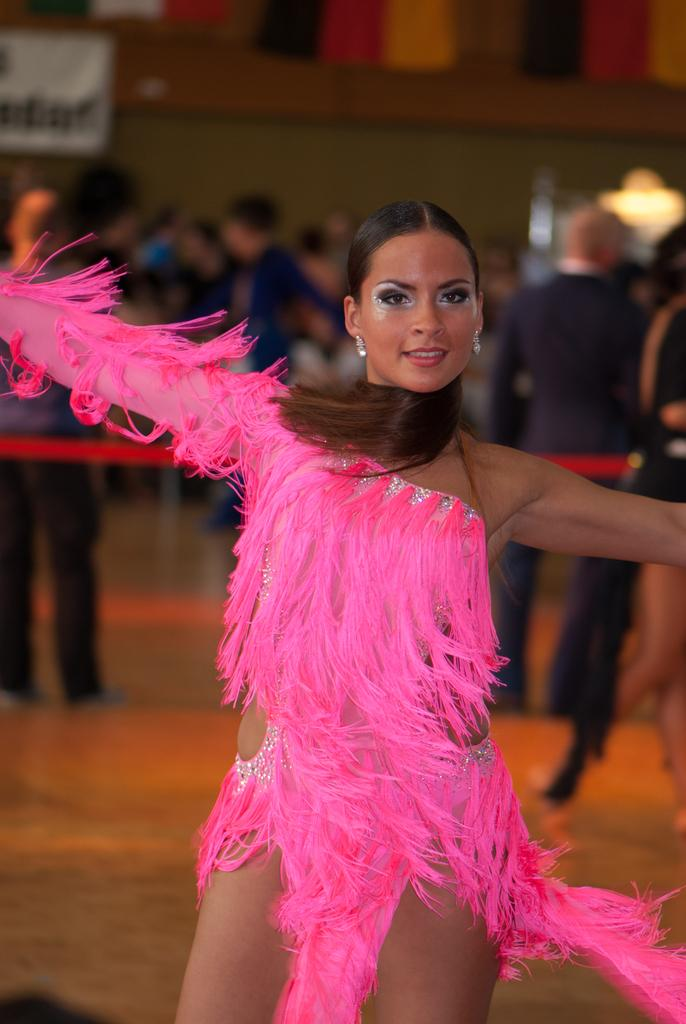Who is the main subject in the image? There is a woman in the image. What is the woman wearing? The woman is wearing a pink dress. What is the woman doing in the image? The woman is dancing on the floor. Can you describe the background of the image? The background of the image is blurred, and there are other persons present. What are some of the other persons in the background doing? Some of the persons in the background are also dancing on the floor. What is the weather like in the image? The provided facts do not mention the weather, so we cannot determine the weather from the image. 